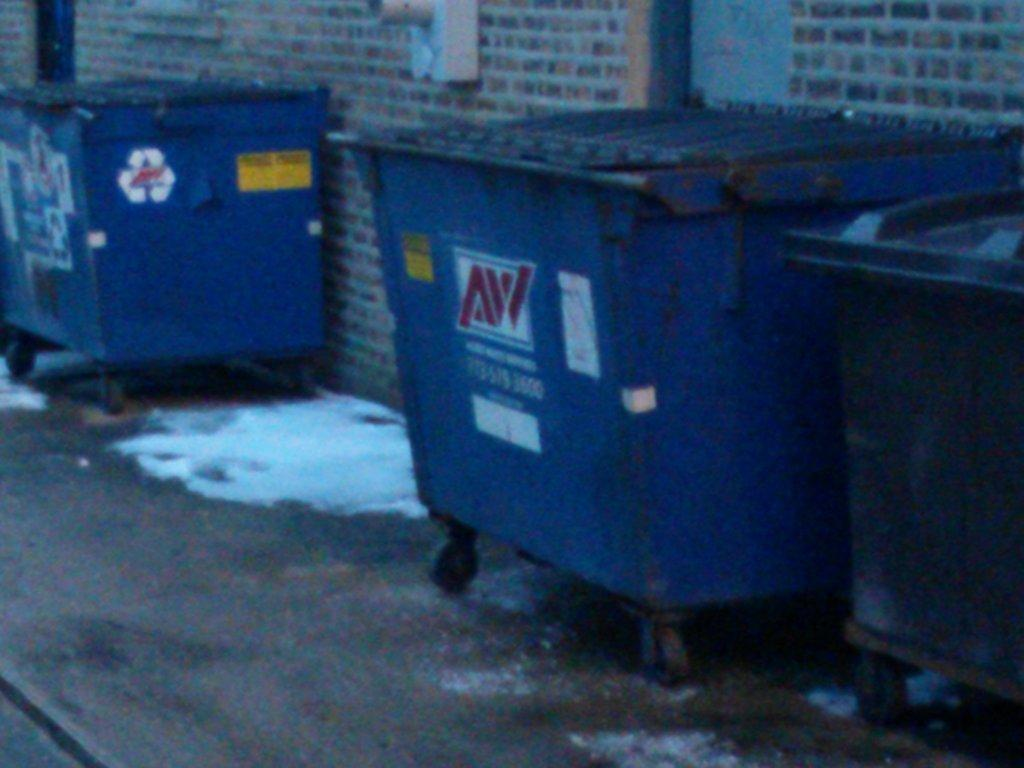<image>
Relay a brief, clear account of the picture shown. A dumpster with AW on the front is next to a brick wall. 